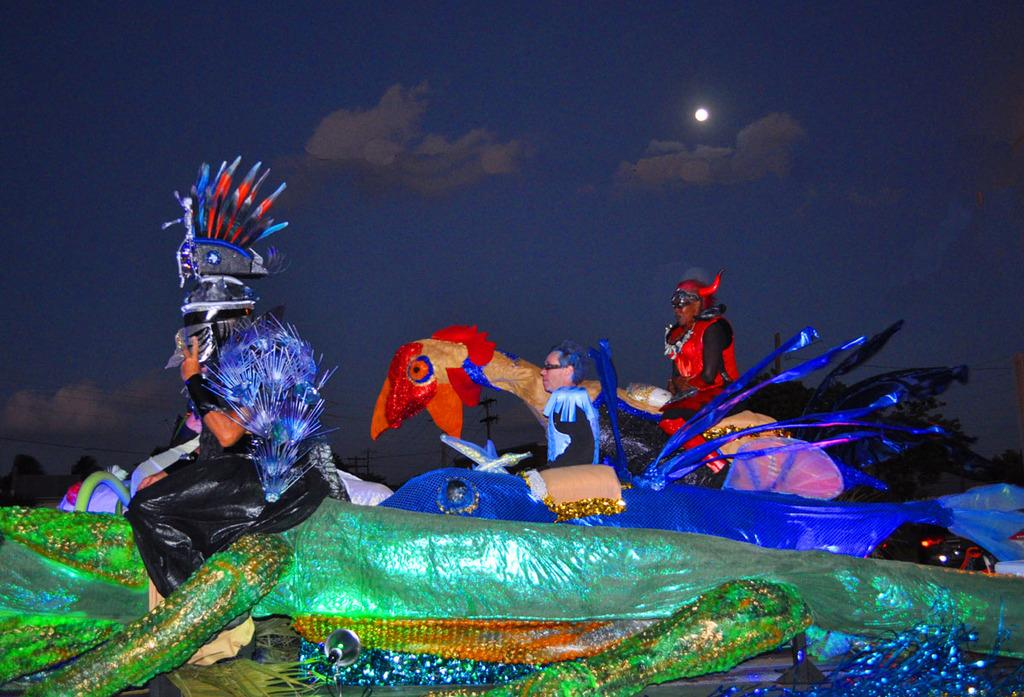What are the persons in the image wearing? The persons in the image are wearing costumes. What are the persons sitting on in the image? The persons are sitting on different colored things. What can be seen in the sky in the background of the image? There is a clear sky in the background of the image, and the moon is visible. What type of tray is being used by the persons in the image? There is no tray present in the image; the persons are sitting on different colored things. What kind of quilt is being used by the persons in the image? There is no quilt present in the image; the persons are wearing costumes and sitting on different colored things. 